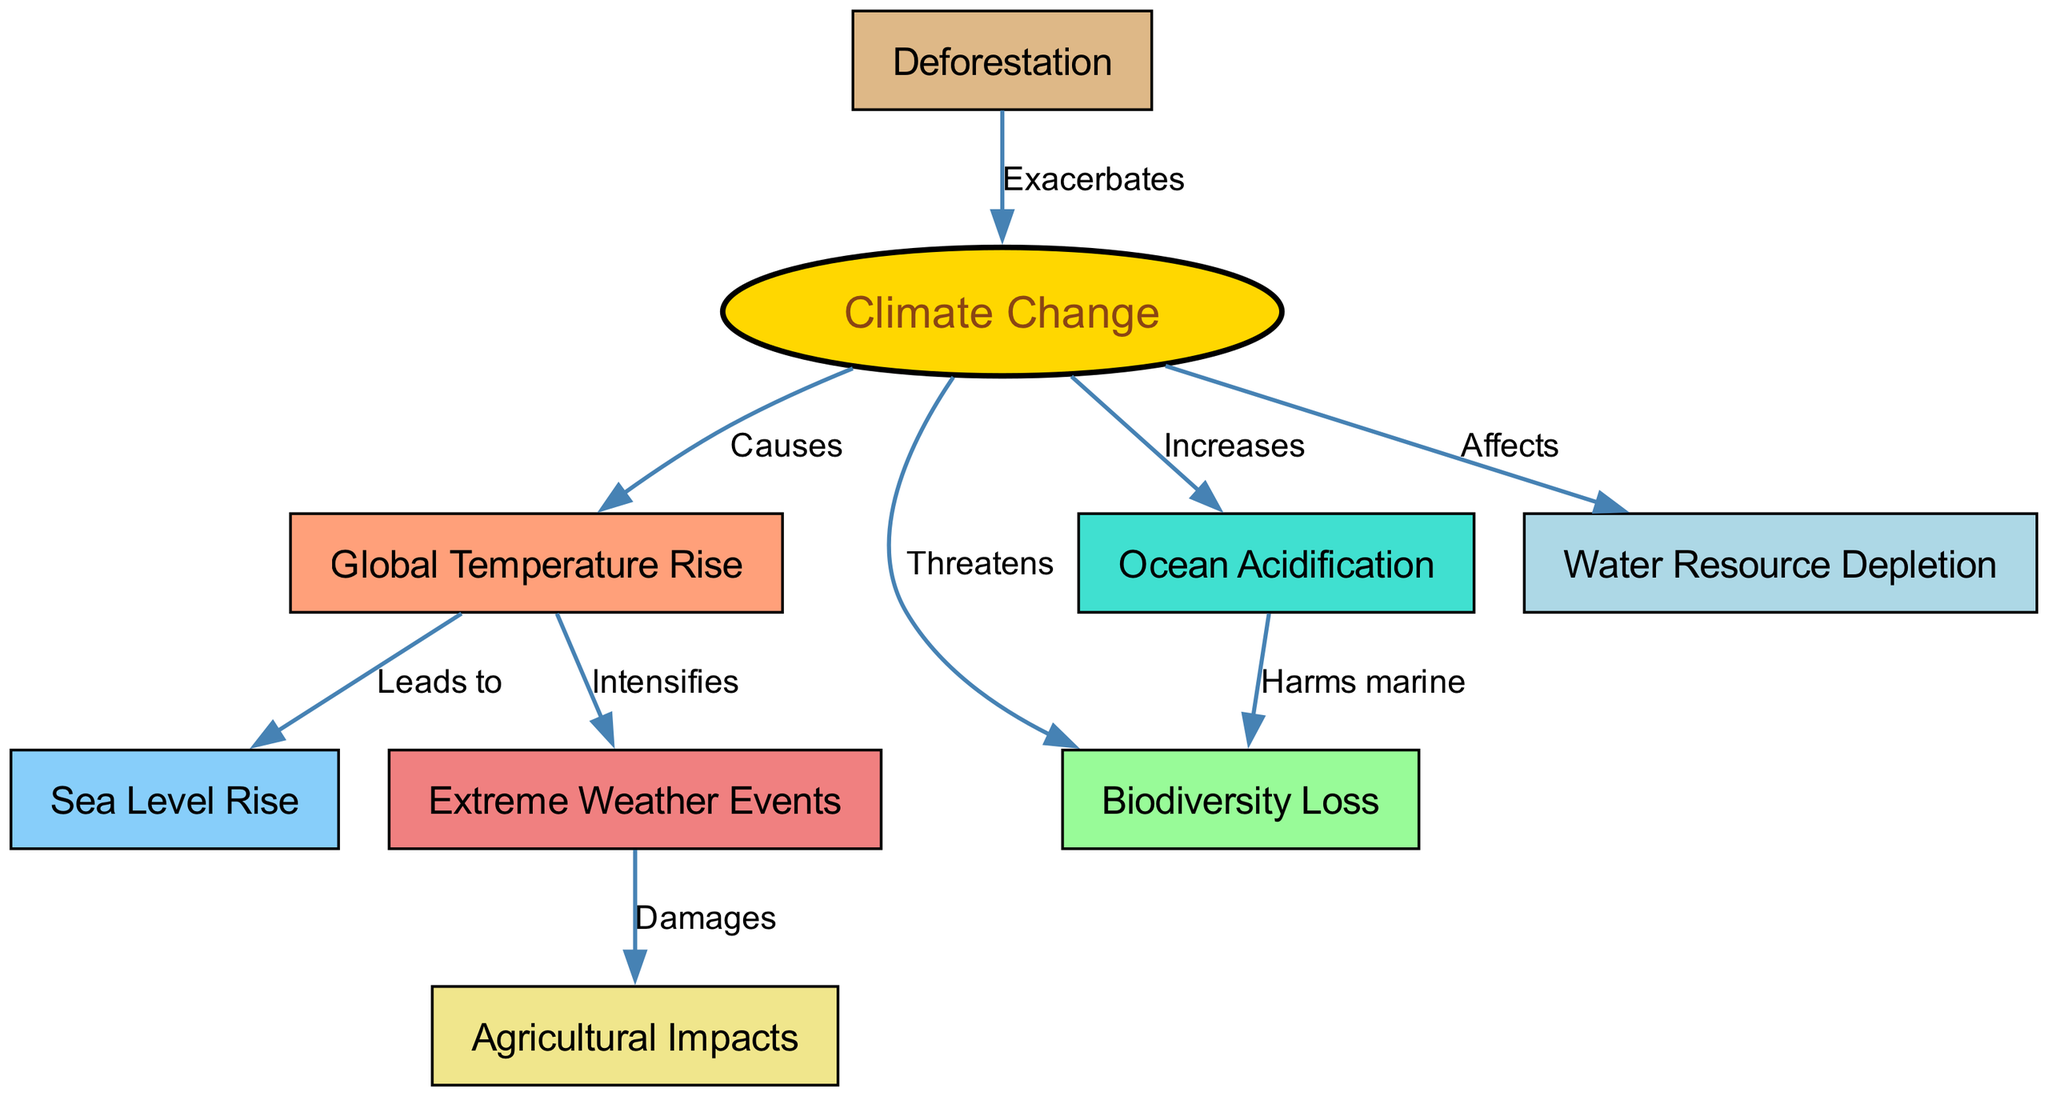What is the primary factor influencing the ecosystem depicted in the diagram? The diagram indicates that "Climate Change" is the central node from which various environmental impacts stem, making it the primary factor influencing the ecosystem.
Answer: Climate Change How many nodes are present in the diagram? By counting the nodes listed, we find a total of 9 distinct nodes representing different environmental factors and impacts.
Answer: 9 Which environmental factor is directly impacted by water resources? The diagram shows that "Water Resource Depletion" is affected directly by "Climate Change," indicating this relationship.
Answer: Climate Change What type of events does global temperature rise intensify? According to the diagram, "Extreme Weather Events" are intensified as a direct consequence of "Global Temperature Rise."
Answer: Extreme Weather Events How does ocean acidification affect biodiversity? The diagram illustrates that "Ocean Acidification" harms "Biodiversity," establishing a direct negative relationship between these two factors.
Answer: Harms marine How does deforestation relate to climate change? The diagram depicts that "Deforestation" exacerbates "Climate Change," indicating a feedback loop where deforestation contributes to climate issues.
Answer: Exacerbates What is the relationship type between temperature rise and sea level? The relationship shown between "Temperature Rise" and "Sea Level Rise" in the diagram is labeled as "Leads to," suggesting that increases in temperature directly cause sea levels to rise.
Answer: Leads to In how many ways does climate change threaten biodiversity? The diagram reveals two distinct relationships: "Climate Change" threatens "Biodiversity Loss" and "Ocean Acidification" also harms marine biodiversity, indicating multiple pathways of threat.
Answer: 2 Which impact does extreme weather damage directly? The diagram shows that "Extreme Weather Events" damages "Agricultural Impacts," outlining the detrimental effects of severe weather on agriculture.
Answer: Damages 